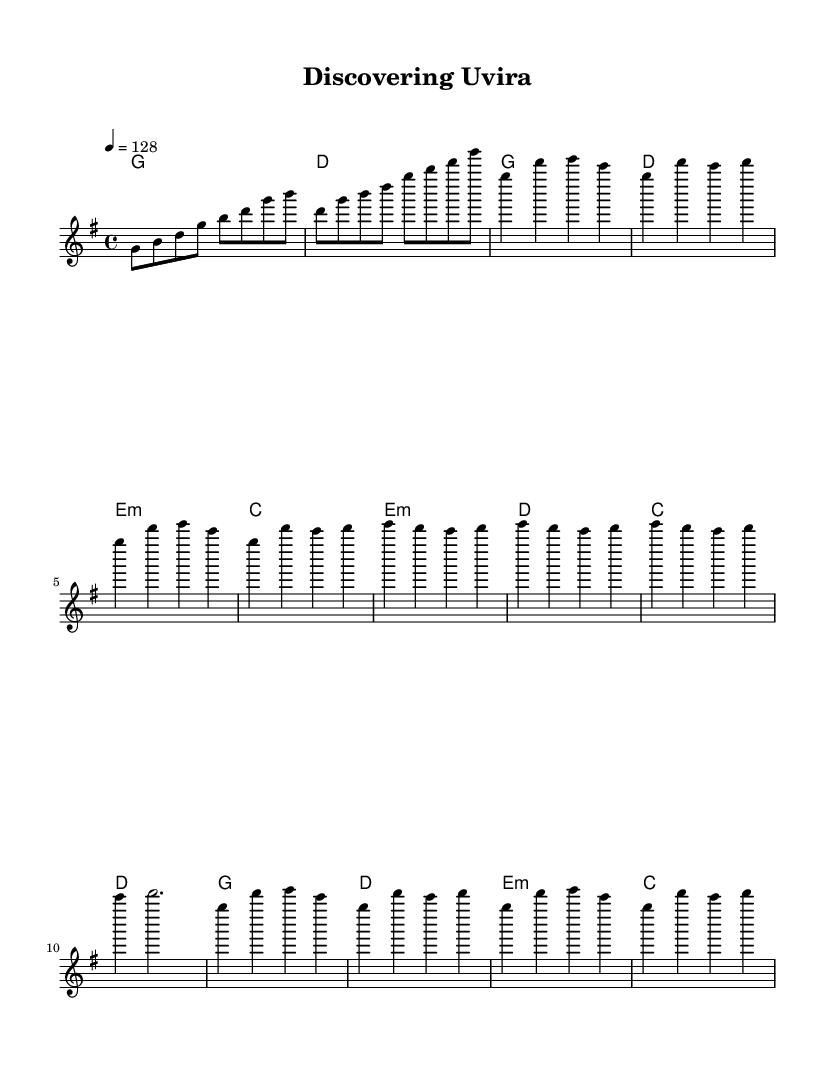What is the key signature of this music? The key signature is G major, which has one sharp (F#). This can be identified by looking at the key signature at the beginning of the score.
Answer: G major What is the time signature of this music? The time signature is 4/4, indicated at the beginning of the sheet music. This means there are four beats in each measure and the quarter note gets one beat.
Answer: 4/4 What is the tempo marking for this music? The tempo marking indicates that the piece should be played at a speed of 128 beats per minute. This is noted at the beginning of the score, specifying the tempo with the marking "4 = 128."
Answer: 128 How many measures are in the verse section? The verse section consists of four measures. This can be determined by counting the measures of the melody labeled as "Verse" in the sheet music.
Answer: 4 What type of chords are used in the pre-chorus? The pre-chorus contains minor chords such as e minor and d minor. By analyzing the chord symbols above the staff during the pre-chorus section, we see that both e:m and d appear.
Answer: Minor What is the last chord of the chorus? The last chord of the chorus is C major. To find this, we look at the chord symbols in the chorus section, noting that the last one displayed corresponds to C.
Answer: C What is the pattern in the chorus melody? The melody in the chorus follows a repeating pattern of notes, specifically four notes that are repeated over the measures. Observing the melody details during the chorus reveal a loop of g, d', e, and c in the measures.
Answer: Repeating pattern 